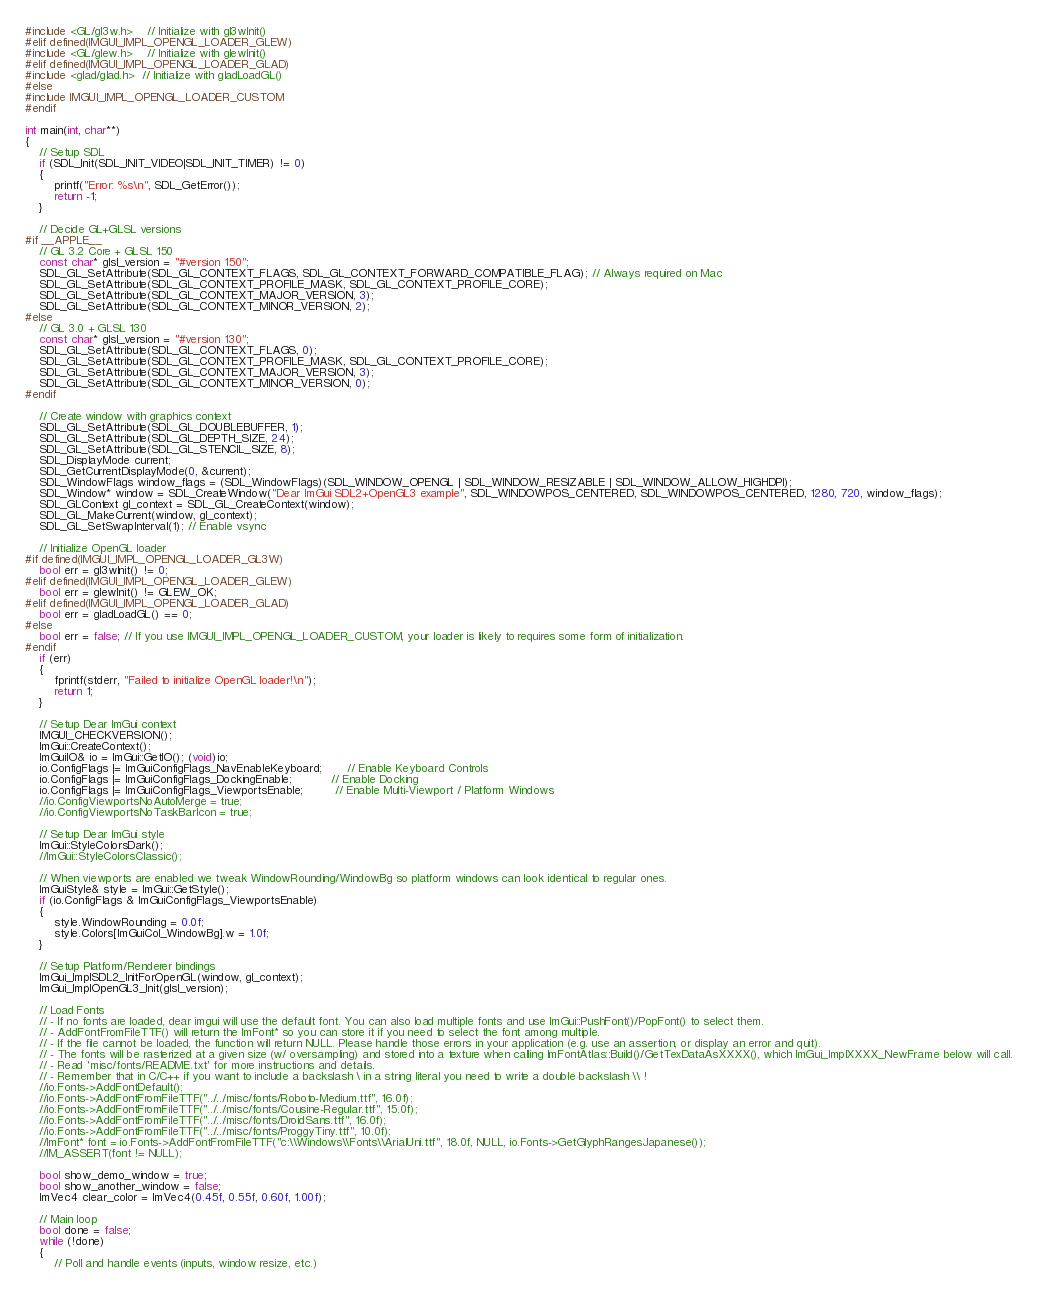Convert code to text. <code><loc_0><loc_0><loc_500><loc_500><_C++_>#include <GL/gl3w.h>    // Initialize with gl3wInit()
#elif defined(IMGUI_IMPL_OPENGL_LOADER_GLEW)
#include <GL/glew.h>    // Initialize with glewInit()
#elif defined(IMGUI_IMPL_OPENGL_LOADER_GLAD)
#include <glad/glad.h>  // Initialize with gladLoadGL()
#else
#include IMGUI_IMPL_OPENGL_LOADER_CUSTOM
#endif

int main(int, char**)
{
    // Setup SDL
    if (SDL_Init(SDL_INIT_VIDEO|SDL_INIT_TIMER) != 0)
    {
        printf("Error: %s\n", SDL_GetError());
        return -1;
    }

    // Decide GL+GLSL versions
#if __APPLE__
    // GL 3.2 Core + GLSL 150
    const char* glsl_version = "#version 150";
    SDL_GL_SetAttribute(SDL_GL_CONTEXT_FLAGS, SDL_GL_CONTEXT_FORWARD_COMPATIBLE_FLAG); // Always required on Mac
    SDL_GL_SetAttribute(SDL_GL_CONTEXT_PROFILE_MASK, SDL_GL_CONTEXT_PROFILE_CORE);
    SDL_GL_SetAttribute(SDL_GL_CONTEXT_MAJOR_VERSION, 3);
    SDL_GL_SetAttribute(SDL_GL_CONTEXT_MINOR_VERSION, 2);
#else
    // GL 3.0 + GLSL 130
    const char* glsl_version = "#version 130";
    SDL_GL_SetAttribute(SDL_GL_CONTEXT_FLAGS, 0);
    SDL_GL_SetAttribute(SDL_GL_CONTEXT_PROFILE_MASK, SDL_GL_CONTEXT_PROFILE_CORE);
    SDL_GL_SetAttribute(SDL_GL_CONTEXT_MAJOR_VERSION, 3);
    SDL_GL_SetAttribute(SDL_GL_CONTEXT_MINOR_VERSION, 0);
#endif

    // Create window with graphics context
    SDL_GL_SetAttribute(SDL_GL_DOUBLEBUFFER, 1);
    SDL_GL_SetAttribute(SDL_GL_DEPTH_SIZE, 24);
    SDL_GL_SetAttribute(SDL_GL_STENCIL_SIZE, 8);
    SDL_DisplayMode current;
    SDL_GetCurrentDisplayMode(0, &current);
    SDL_WindowFlags window_flags = (SDL_WindowFlags)(SDL_WINDOW_OPENGL | SDL_WINDOW_RESIZABLE | SDL_WINDOW_ALLOW_HIGHDPI);
    SDL_Window* window = SDL_CreateWindow("Dear ImGui SDL2+OpenGL3 example", SDL_WINDOWPOS_CENTERED, SDL_WINDOWPOS_CENTERED, 1280, 720, window_flags);
    SDL_GLContext gl_context = SDL_GL_CreateContext(window);
    SDL_GL_MakeCurrent(window, gl_context);
    SDL_GL_SetSwapInterval(1); // Enable vsync

    // Initialize OpenGL loader
#if defined(IMGUI_IMPL_OPENGL_LOADER_GL3W)
    bool err = gl3wInit() != 0;
#elif defined(IMGUI_IMPL_OPENGL_LOADER_GLEW)
    bool err = glewInit() != GLEW_OK;
#elif defined(IMGUI_IMPL_OPENGL_LOADER_GLAD)
    bool err = gladLoadGL() == 0;
#else
    bool err = false; // If you use IMGUI_IMPL_OPENGL_LOADER_CUSTOM, your loader is likely to requires some form of initialization.
#endif
    if (err)
    {
        fprintf(stderr, "Failed to initialize OpenGL loader!\n");
        return 1;
    }

    // Setup Dear ImGui context
    IMGUI_CHECKVERSION();
    ImGui::CreateContext();
    ImGuiIO& io = ImGui::GetIO(); (void)io;
    io.ConfigFlags |= ImGuiConfigFlags_NavEnableKeyboard;       // Enable Keyboard Controls
    io.ConfigFlags |= ImGuiConfigFlags_DockingEnable;           // Enable Docking
    io.ConfigFlags |= ImGuiConfigFlags_ViewportsEnable;         // Enable Multi-Viewport / Platform Windows
    //io.ConfigViewportsNoAutoMerge = true;
    //io.ConfigViewportsNoTaskBarIcon = true;

    // Setup Dear ImGui style
    ImGui::StyleColorsDark();
    //ImGui::StyleColorsClassic();

    // When viewports are enabled we tweak WindowRounding/WindowBg so platform windows can look identical to regular ones.
    ImGuiStyle& style = ImGui::GetStyle();
    if (io.ConfigFlags & ImGuiConfigFlags_ViewportsEnable)
    {
        style.WindowRounding = 0.0f;
        style.Colors[ImGuiCol_WindowBg].w = 1.0f;
    }

    // Setup Platform/Renderer bindings
    ImGui_ImplSDL2_InitForOpenGL(window, gl_context);
    ImGui_ImplOpenGL3_Init(glsl_version);

    // Load Fonts
    // - If no fonts are loaded, dear imgui will use the default font. You can also load multiple fonts and use ImGui::PushFont()/PopFont() to select them.
    // - AddFontFromFileTTF() will return the ImFont* so you can store it if you need to select the font among multiple.
    // - If the file cannot be loaded, the function will return NULL. Please handle those errors in your application (e.g. use an assertion, or display an error and quit).
    // - The fonts will be rasterized at a given size (w/ oversampling) and stored into a texture when calling ImFontAtlas::Build()/GetTexDataAsXXXX(), which ImGui_ImplXXXX_NewFrame below will call.
    // - Read 'misc/fonts/README.txt' for more instructions and details.
    // - Remember that in C/C++ if you want to include a backslash \ in a string literal you need to write a double backslash \\ !
    //io.Fonts->AddFontDefault();
    //io.Fonts->AddFontFromFileTTF("../../misc/fonts/Roboto-Medium.ttf", 16.0f);
    //io.Fonts->AddFontFromFileTTF("../../misc/fonts/Cousine-Regular.ttf", 15.0f);
    //io.Fonts->AddFontFromFileTTF("../../misc/fonts/DroidSans.ttf", 16.0f);
    //io.Fonts->AddFontFromFileTTF("../../misc/fonts/ProggyTiny.ttf", 10.0f);
    //ImFont* font = io.Fonts->AddFontFromFileTTF("c:\\Windows\\Fonts\\ArialUni.ttf", 18.0f, NULL, io.Fonts->GetGlyphRangesJapanese());
    //IM_ASSERT(font != NULL);

    bool show_demo_window = true;
    bool show_another_window = false;
    ImVec4 clear_color = ImVec4(0.45f, 0.55f, 0.60f, 1.00f);

    // Main loop
    bool done = false;
    while (!done)
    {
        // Poll and handle events (inputs, window resize, etc.)</code> 